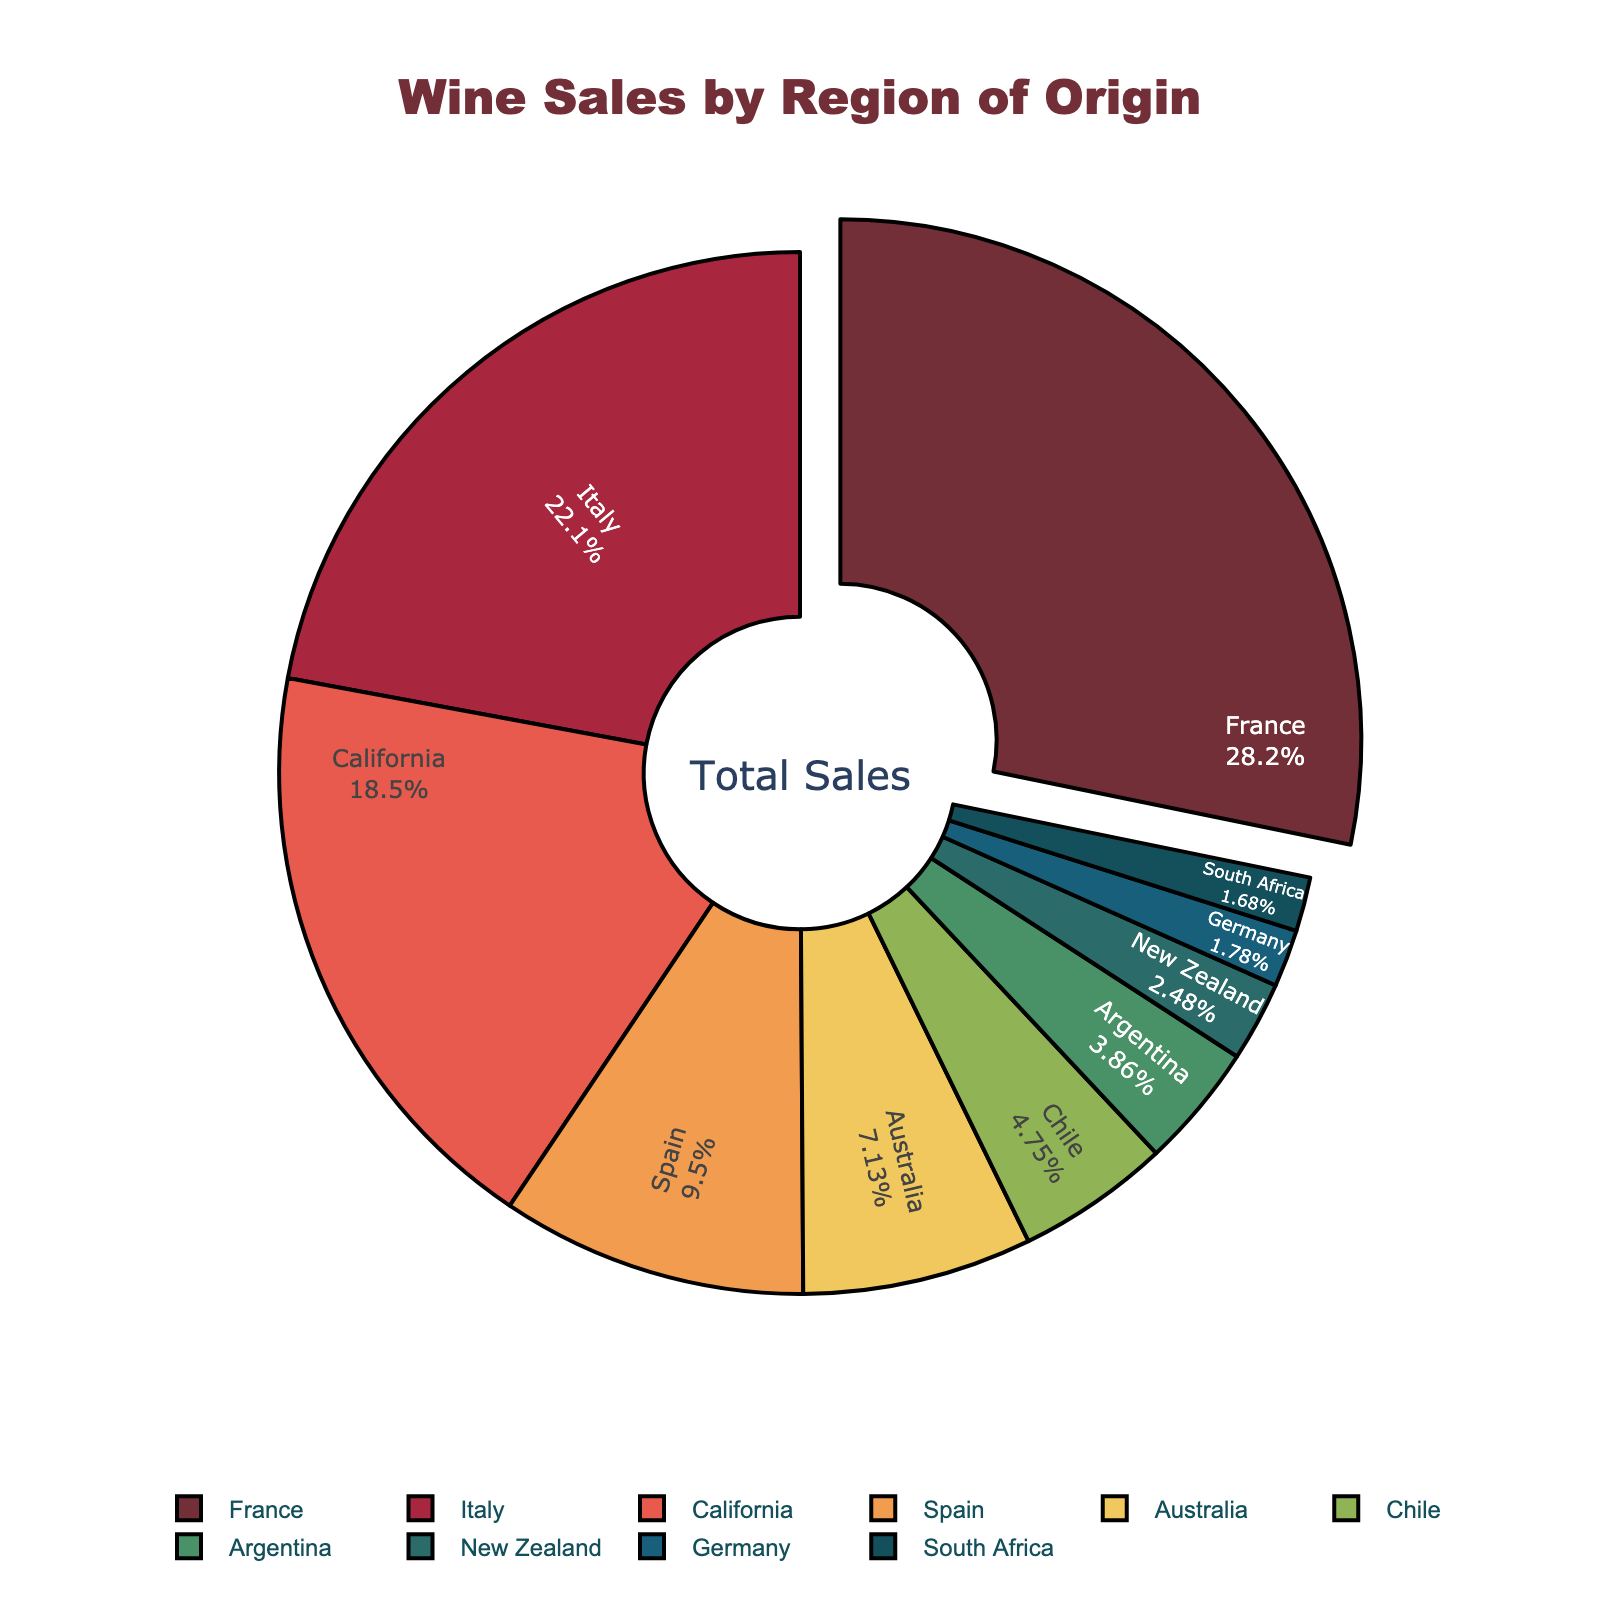What percentage of wine sales does California account for? Look for the slice labeled 'California' to identify its proportion. California accounts for 18.7% of the total wine sales.
Answer: 18.7% Which region has the highest percentage of wine sales? Observe the labels and their corresponding percentages. The region with the largest percentage will have the slice pulled out slightly. France, with a peel-out effect, has the highest percentage of 28.5%.
Answer: France What is the combined percentage of wine sales for Italy and Spain? Add the percentage values for Italy (22.3%) and Spain (9.6%). 22.3% + 9.6% = 31.9%.
Answer: 31.9% How much more wine is sold in France compared to Chile? Subtract the percentage of Chile (4.8%) from the percentage of France (28.5%). 28.5% - 4.8% = 23.7%.
Answer: 23.7% Is Italy’s wine sales percentage greater than the combined percentage of Germany and South Africa? Add the percentages of Germany (1.8%) and South Africa (1.7%). 1.8% + 1.7% = 3.5%. Compare this with Italy’s percentage (22.3%). Italy's percentage (22.3%) is greater than the combined percentage of Germany and South Africa (3.5%).
Answer: Yes What regions have less than 5% of the total wine sales? Identify all slices with a percentage less than 5%. These are Chile (4.8%), Argentina (3.9%), New Zealand (2.5%), Germany (1.8%), and South Africa (1.7%).
Answer: Chile, Argentina, New Zealand, Germany, South Africa What is the average percentage of wine sales for Australia, Chile, and Argentina? Add the percentages for Australia (7.2%), Chile (4.8%), and Argentina (3.9%), then divide by 3. (7.2% + 4.8% + 3.9%) / 3 = 5.3%.
Answer: 5.3% Compare the wine sales percentage of California to Australia. Is California's percentage higher? Compare the percentages directly. California (18.7%) vs. Australia (7.2%). California’s 18.7% is higher than Australia’s 7.2%.
Answer: Yes Which regions together account for more than 50% of the wine sales? Sum up the largest segments until the total exceeds 50%. France (28.5%) + Italy (22.3%) = 50.8%.
Answer: France and Italy What is the percentage difference between the highest and lowest wine sales regions? Subtract the smallest percentage (South Africa, 1.7%) from the largest percentage (France, 28.5%). 28.5% - 1.7% = 26.8%.
Answer: 26.8% 